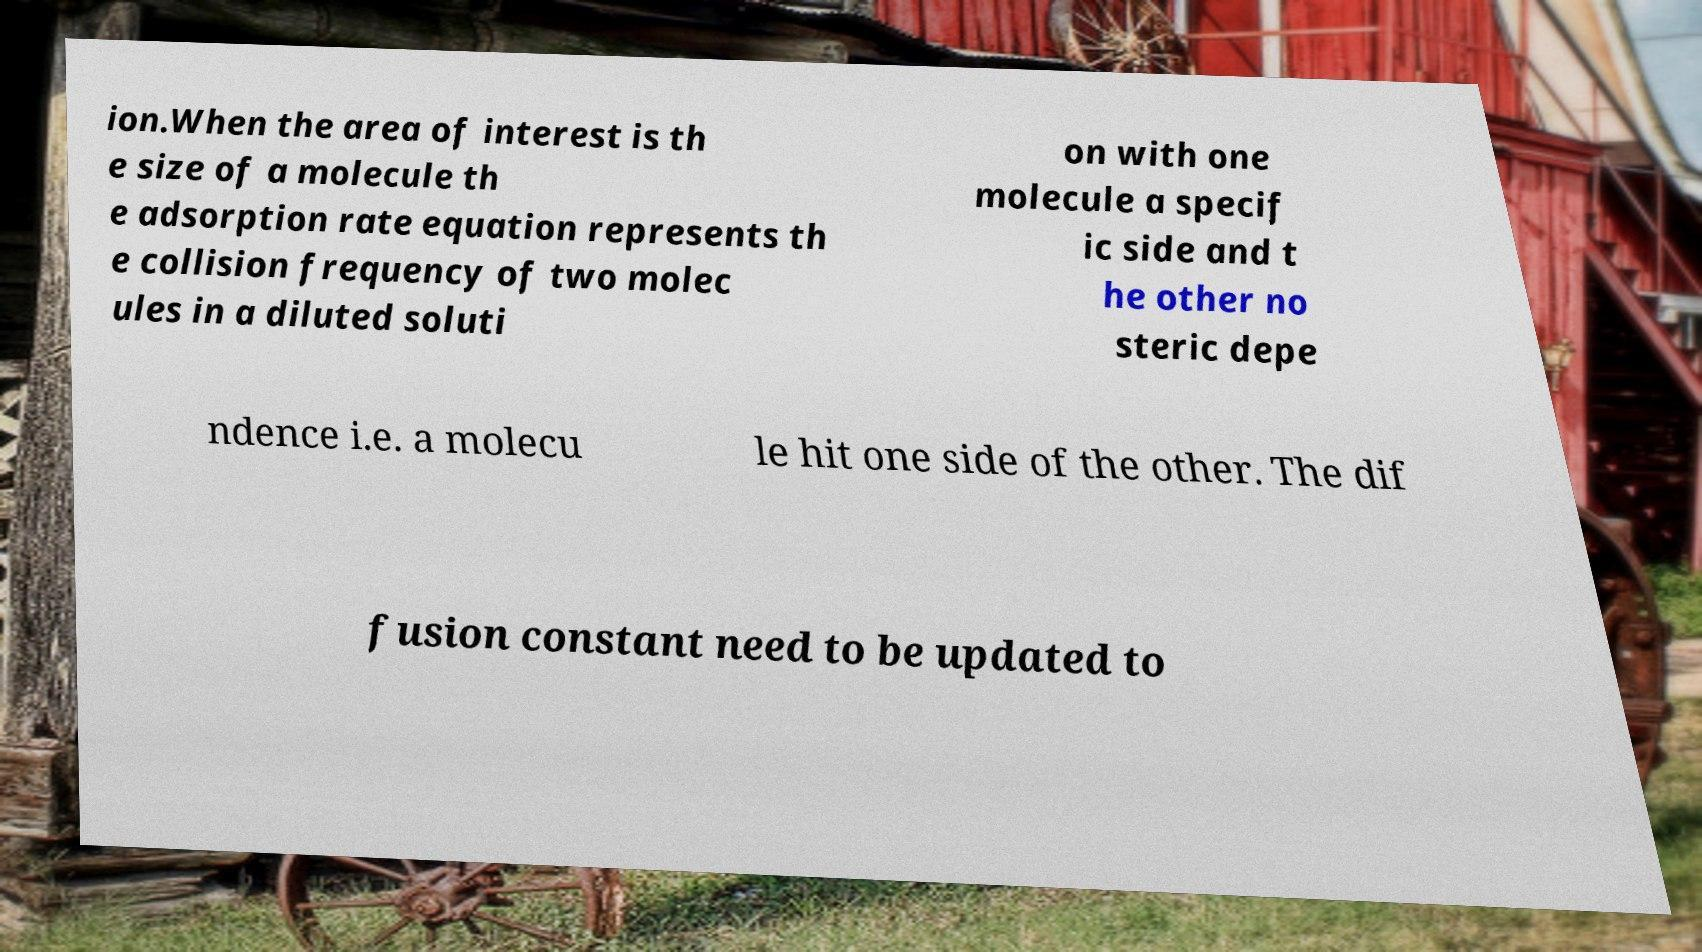Please read and relay the text visible in this image. What does it say? ion.When the area of interest is th e size of a molecule th e adsorption rate equation represents th e collision frequency of two molec ules in a diluted soluti on with one molecule a specif ic side and t he other no steric depe ndence i.e. a molecu le hit one side of the other. The dif fusion constant need to be updated to 